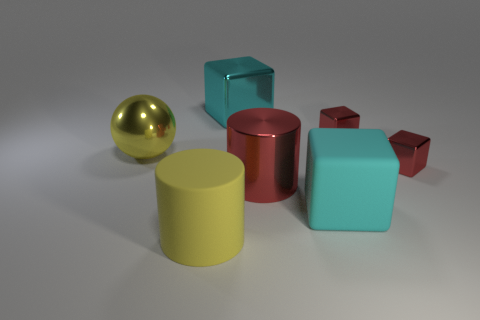What is the large yellow cylinder made of?
Offer a very short reply. Rubber. What is the big block in front of the red metallic block that is to the right of the red shiny block behind the big yellow shiny object made of?
Your answer should be compact. Rubber. There is a yellow sphere; is it the same size as the cyan block that is in front of the big yellow sphere?
Give a very brief answer. Yes. What number of objects are rubber objects to the left of the big matte cube or things that are right of the yellow rubber cylinder?
Your answer should be compact. 6. There is a shiny object to the left of the large cyan metallic cube; what is its color?
Provide a succinct answer. Yellow. Is there a cyan matte object that is right of the cylinder behind the large yellow cylinder?
Make the answer very short. Yes. Is the number of small cyan matte cylinders less than the number of big yellow cylinders?
Your response must be concise. Yes. The large cyan object that is behind the tiny metal thing that is behind the yellow metallic sphere is made of what material?
Provide a short and direct response. Metal. Does the cyan metallic cube have the same size as the yellow shiny sphere?
Provide a succinct answer. Yes. What number of things are either large balls or tiny green objects?
Your response must be concise. 1. 